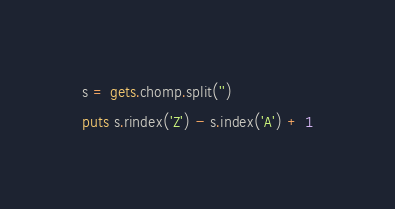Convert code to text. <code><loc_0><loc_0><loc_500><loc_500><_Ruby_>s = gets.chomp.split('')

puts s.rindex('Z') - s.index('A') + 1</code> 